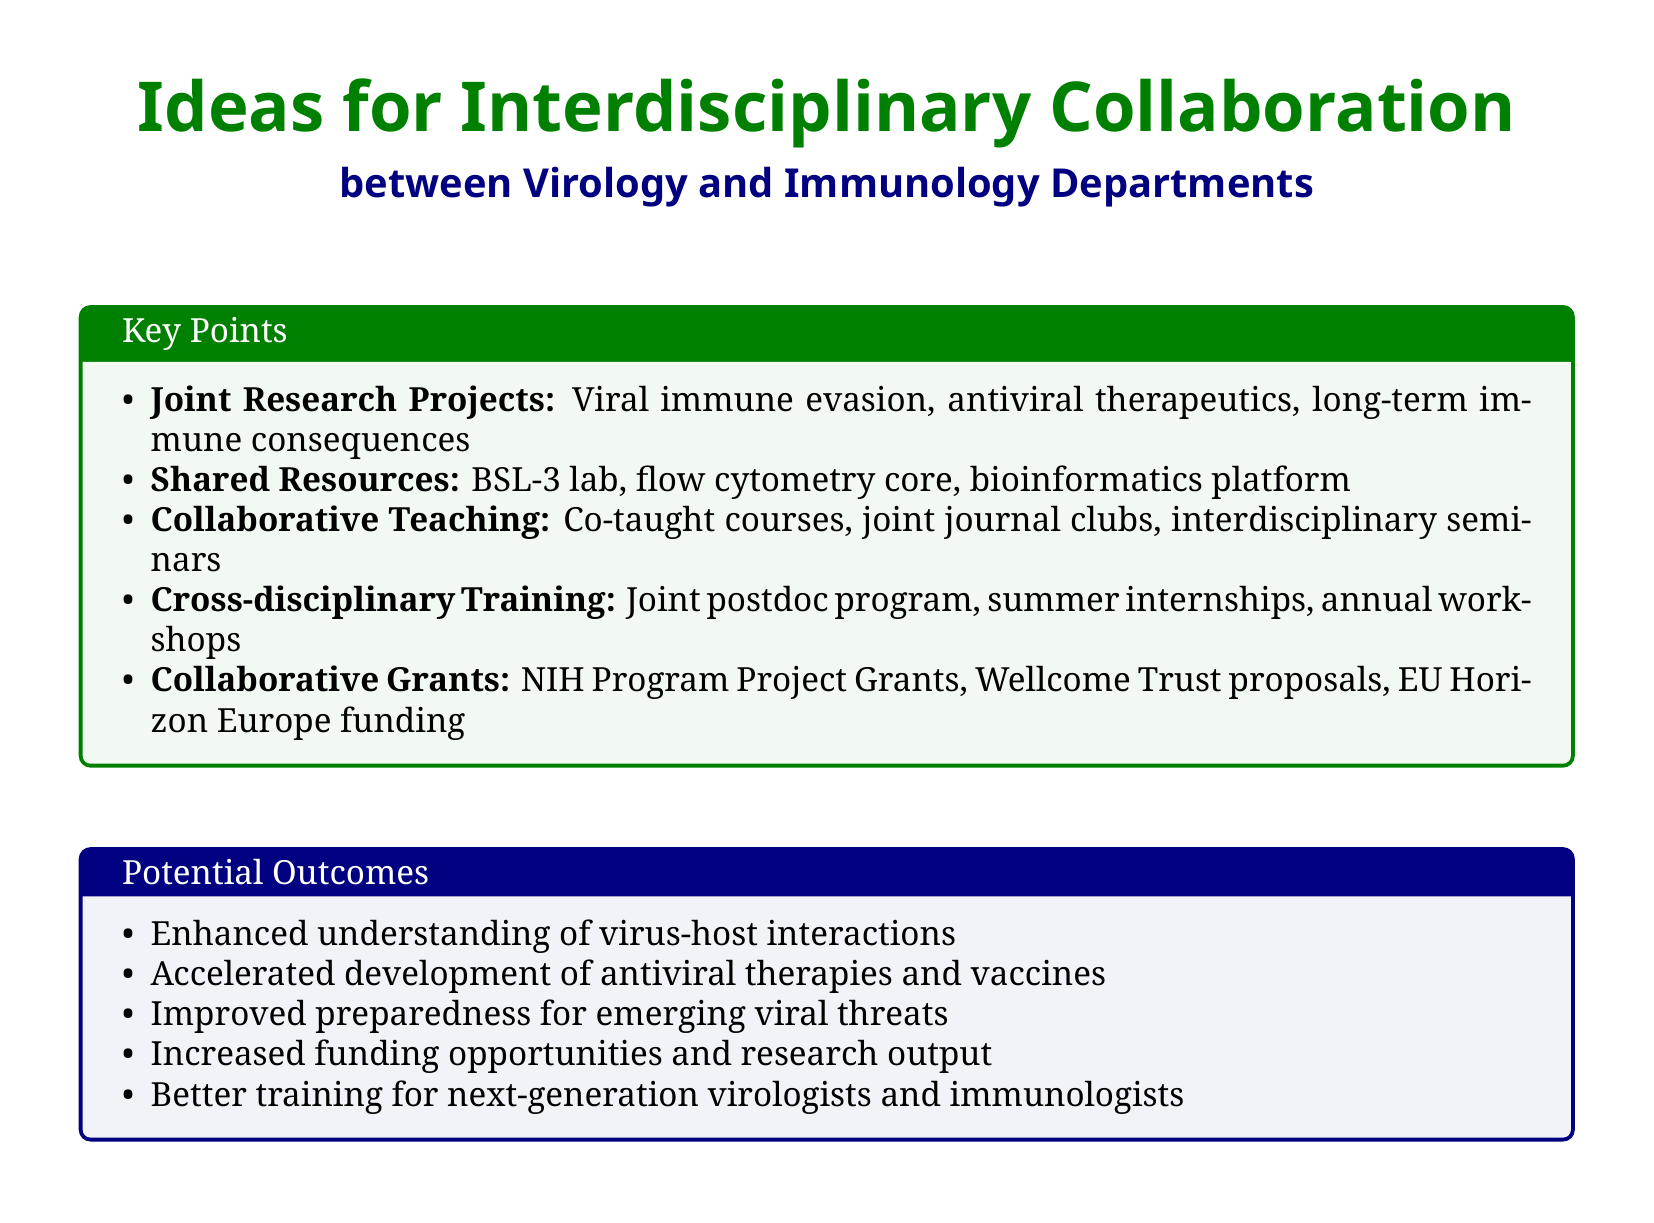What are three topics of joint research projects? The document lists viral immune evasion mechanisms, antiviral therapeutics targeting host immune responses, and long-term immune consequences of viral infections as joint research projects.
Answer: Viral immune evasion, antiviral therapeutics, long-term immune consequences What facility is suggested to be shared between departments? The document recommends establishing a shared BSL-3 laboratory for studying highly pathogenic viruses.
Answer: BSL-3 laboratory What is one outcome of interdisciplinary collaboration mentioned? The document outlines enhanced understanding of virus-host interactions as a potential outcome of collaboration.
Answer: Enhanced understanding of virus-host interactions How many collaborative grant proposal ideas are listed? The document enumerates three collaborative grant proposal ideas: NIH Program Project Grants, Wellcome Trust proposals, and EU Horizon Europe funding.
Answer: Three What type of program is proposed for cross-disciplinary training? The document states that a joint postdoctoral fellowship program is proposed for cross-disciplinary training.
Answer: Joint postdoctoral fellowship program What is the purpose of collaborative teaching initiatives? The document describes the purpose of collaborative teaching initiatives as enhancing the educational experience through co-teaching and joint seminars.
Answer: Enhancing the educational experience How many items are listed under shared resources and facilities? The document outlines three items under shared resources and facilities: a BSL-3 lab, a flow cytometry core facility, and a bioinformatics platform.
Answer: Three What is one specific topic for co-teaching mentioned? The document mentions co-teaching a graduate-level course on "Virus-Host Interactions" as a specific topic for collaborative teaching.
Answer: Virus-Host Interactions 